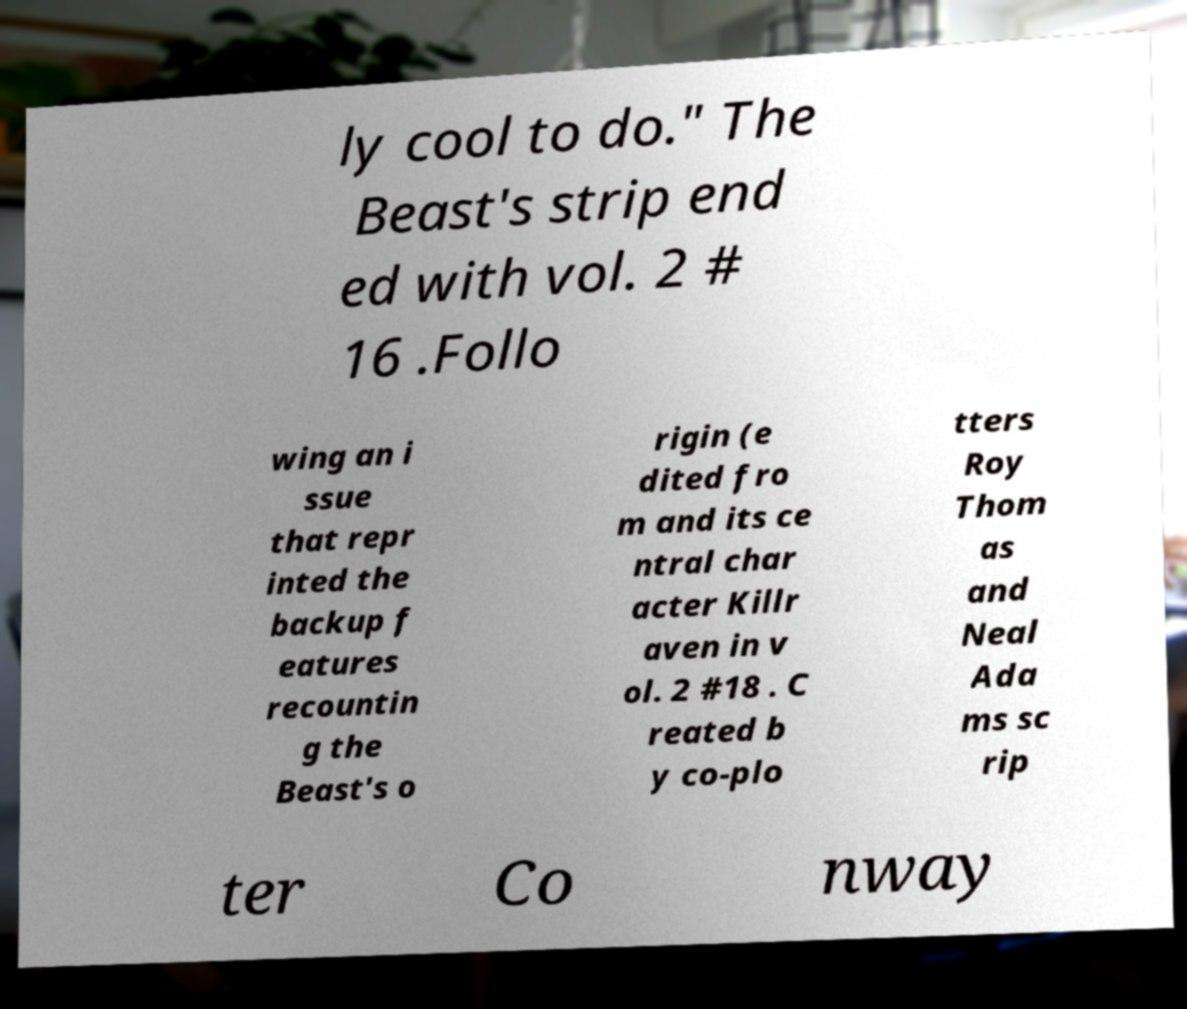There's text embedded in this image that I need extracted. Can you transcribe it verbatim? ly cool to do." The Beast's strip end ed with vol. 2 # 16 .Follo wing an i ssue that repr inted the backup f eatures recountin g the Beast's o rigin (e dited fro m and its ce ntral char acter Killr aven in v ol. 2 #18 . C reated b y co-plo tters Roy Thom as and Neal Ada ms sc rip ter Co nway 